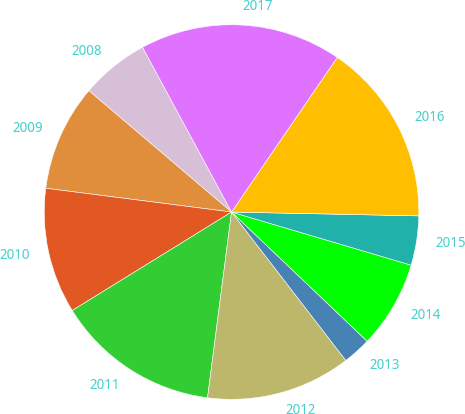Convert chart. <chart><loc_0><loc_0><loc_500><loc_500><pie_chart><fcel>2008<fcel>2009<fcel>2010<fcel>2011<fcel>2012<fcel>2013<fcel>2014<fcel>2015<fcel>2016<fcel>2017<nl><fcel>5.9%<fcel>9.19%<fcel>10.84%<fcel>14.14%<fcel>12.49%<fcel>2.44%<fcel>7.54%<fcel>4.25%<fcel>15.78%<fcel>17.43%<nl></chart> 